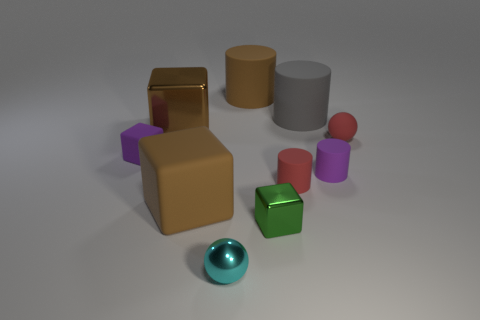Subtract all gray cylinders. How many brown blocks are left? 2 Subtract all red matte cylinders. How many cylinders are left? 3 Subtract all gray cylinders. How many cylinders are left? 3 Subtract 1 cylinders. How many cylinders are left? 3 Subtract all cylinders. How many objects are left? 6 Subtract all big brown objects. Subtract all gray objects. How many objects are left? 6 Add 6 small purple matte cylinders. How many small purple matte cylinders are left? 7 Add 9 gray cylinders. How many gray cylinders exist? 10 Subtract 0 gray cubes. How many objects are left? 10 Subtract all gray cylinders. Subtract all blue balls. How many cylinders are left? 3 